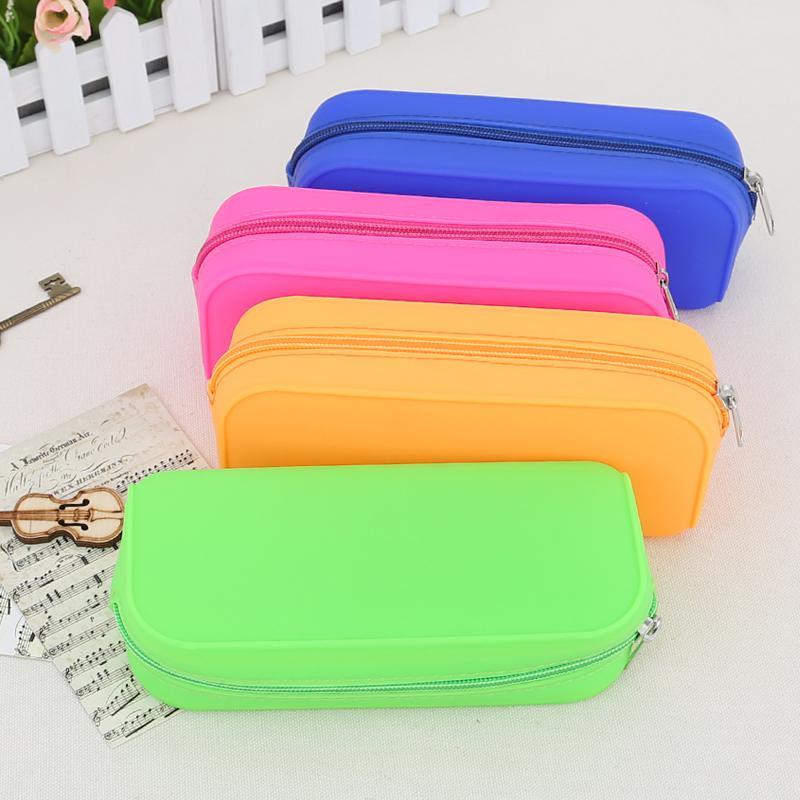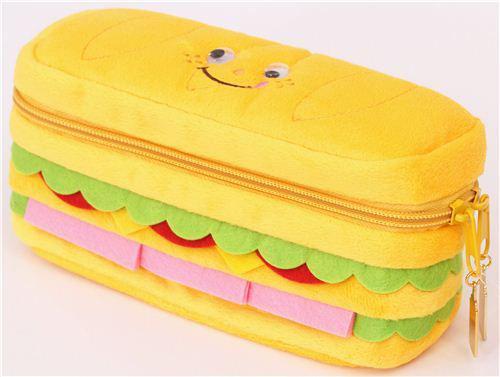The first image is the image on the left, the second image is the image on the right. Analyze the images presented: Is the assertion "There's exactly four small bags in the left image." valid? Answer yes or no. Yes. The first image is the image on the left, the second image is the image on the right. Assess this claim about the two images: "At least one image shows exactly four pencil cases of different solid colors.". Correct or not? Answer yes or no. Yes. 